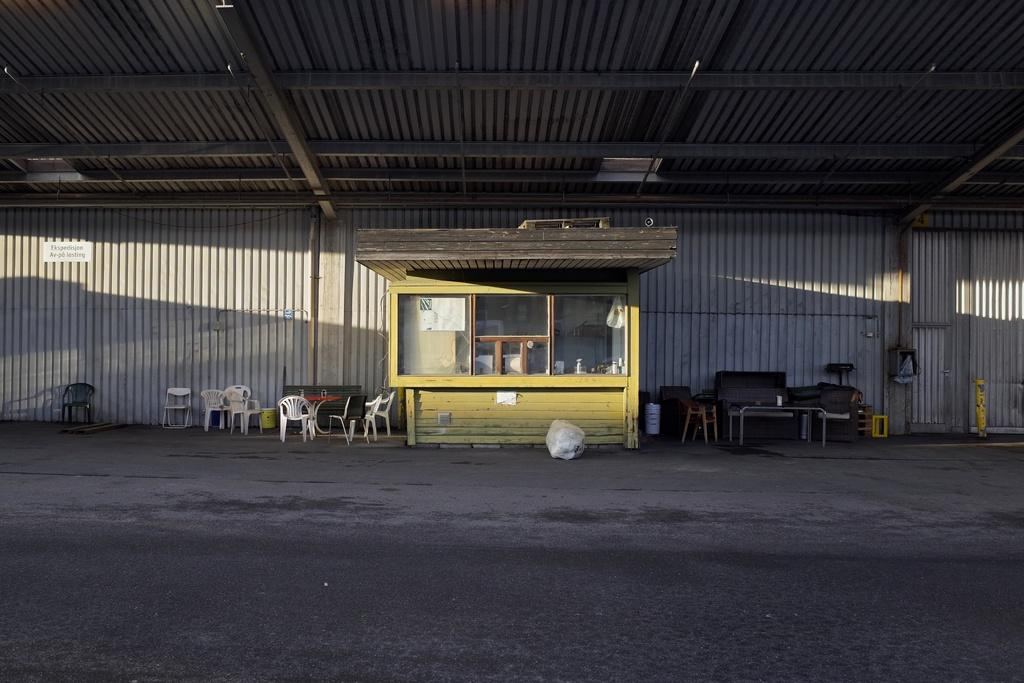What type of establishment is shown in the image? There is a store in the image. What type of seating is available under the shed? Chairs and tables are present under a shed. What material is used for the rods visible in the image? The rods visible in the image are made of metal. What is the governor doing in the image? There is no governor present in the image. How many heads can be seen in the image? There is no mention of heads or people in the image, so it cannot be determined from the facts provided. 